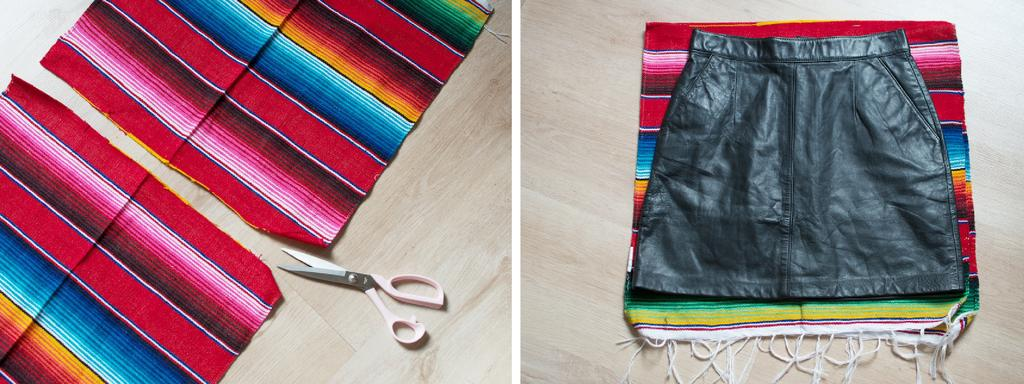What type of artwork is shown in the image? The image is a collage of two images. What can be seen in the collage besides the images? Clothes are present in the collage. What tool is visible in the collage? A scissor is visible in the collage. What type of plants are being sorted in the image? There are no plants present in the image; it is a collage of images and contains clothes and a scissor. 